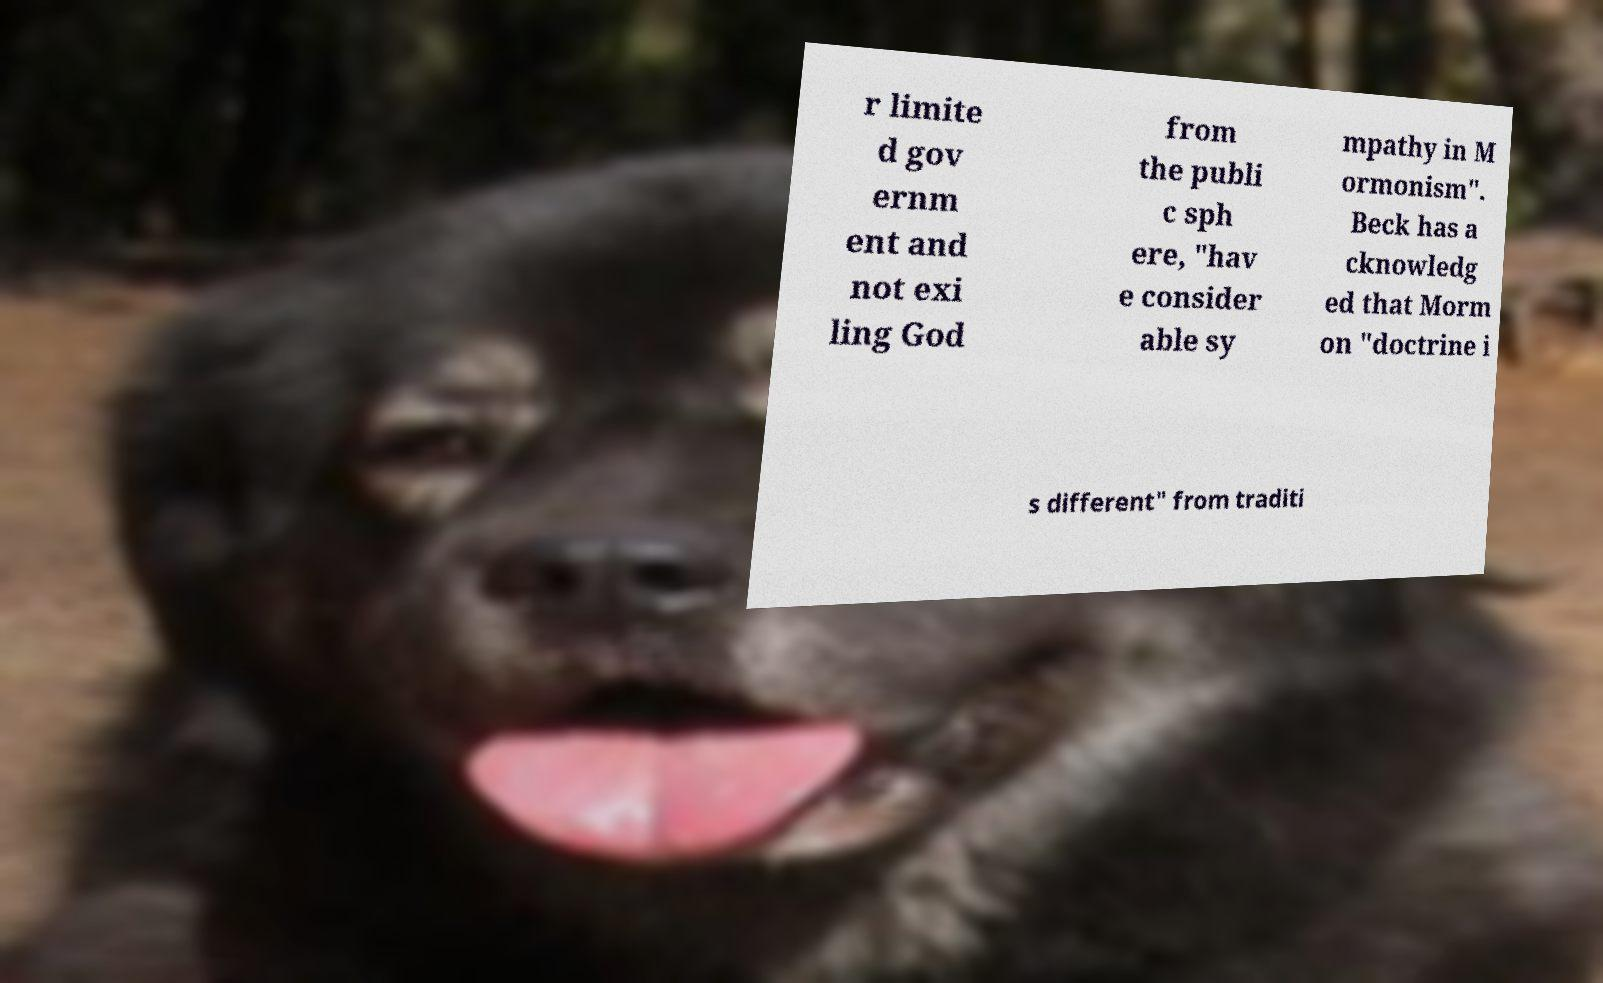What messages or text are displayed in this image? I need them in a readable, typed format. r limite d gov ernm ent and not exi ling God from the publi c sph ere, "hav e consider able sy mpathy in M ormonism". Beck has a cknowledg ed that Morm on "doctrine i s different" from traditi 